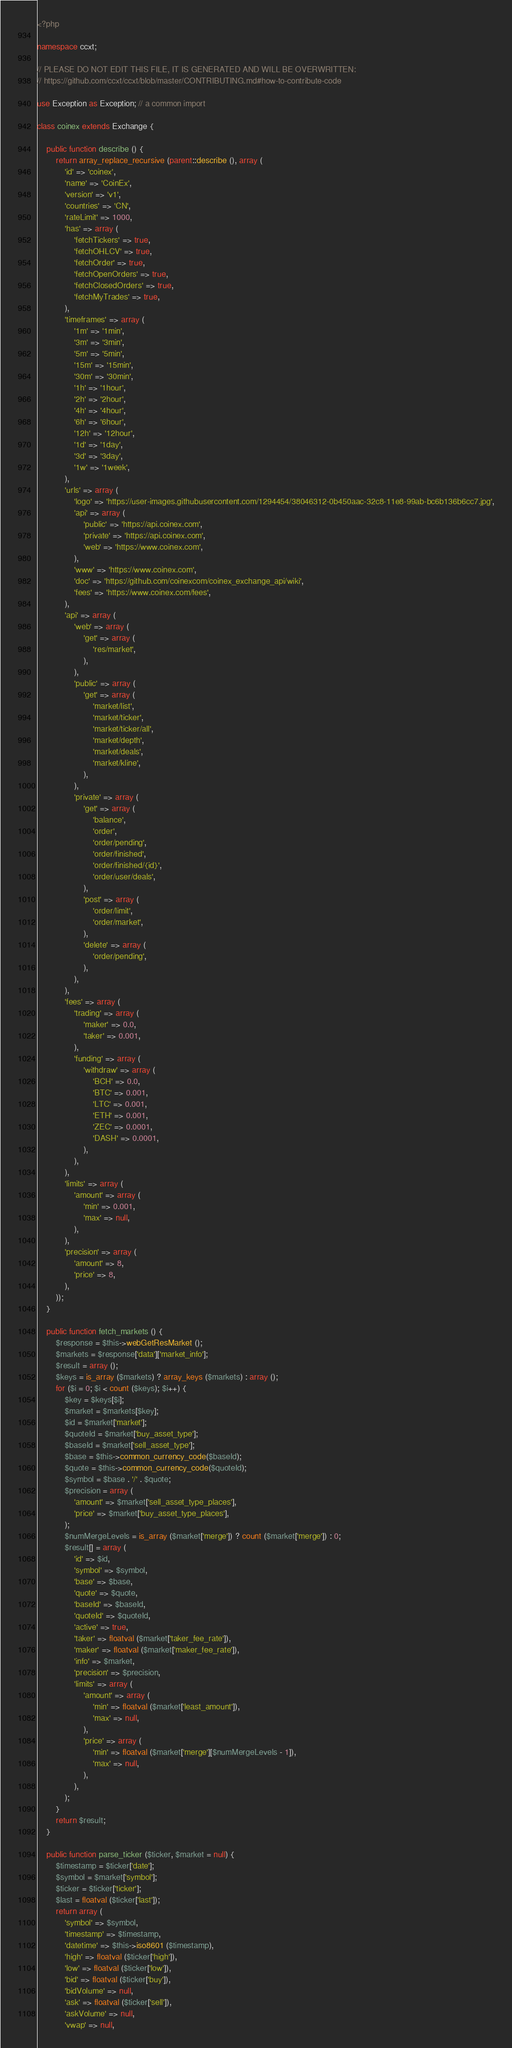<code> <loc_0><loc_0><loc_500><loc_500><_PHP_><?php

namespace ccxt;

// PLEASE DO NOT EDIT THIS FILE, IT IS GENERATED AND WILL BE OVERWRITTEN:
// https://github.com/ccxt/ccxt/blob/master/CONTRIBUTING.md#how-to-contribute-code

use Exception as Exception; // a common import

class coinex extends Exchange {

    public function describe () {
        return array_replace_recursive (parent::describe (), array (
            'id' => 'coinex',
            'name' => 'CoinEx',
            'version' => 'v1',
            'countries' => 'CN',
            'rateLimit' => 1000,
            'has' => array (
                'fetchTickers' => true,
                'fetchOHLCV' => true,
                'fetchOrder' => true,
                'fetchOpenOrders' => true,
                'fetchClosedOrders' => true,
                'fetchMyTrades' => true,
            ),
            'timeframes' => array (
                '1m' => '1min',
                '3m' => '3min',
                '5m' => '5min',
                '15m' => '15min',
                '30m' => '30min',
                '1h' => '1hour',
                '2h' => '2hour',
                '4h' => '4hour',
                '6h' => '6hour',
                '12h' => '12hour',
                '1d' => '1day',
                '3d' => '3day',
                '1w' => '1week',
            ),
            'urls' => array (
                'logo' => 'https://user-images.githubusercontent.com/1294454/38046312-0b450aac-32c8-11e8-99ab-bc6b136b6cc7.jpg',
                'api' => array (
                    'public' => 'https://api.coinex.com',
                    'private' => 'https://api.coinex.com',
                    'web' => 'https://www.coinex.com',
                ),
                'www' => 'https://www.coinex.com',
                'doc' => 'https://github.com/coinexcom/coinex_exchange_api/wiki',
                'fees' => 'https://www.coinex.com/fees',
            ),
            'api' => array (
                'web' => array (
                    'get' => array (
                        'res/market',
                    ),
                ),
                'public' => array (
                    'get' => array (
                        'market/list',
                        'market/ticker',
                        'market/ticker/all',
                        'market/depth',
                        'market/deals',
                        'market/kline',
                    ),
                ),
                'private' => array (
                    'get' => array (
                        'balance',
                        'order',
                        'order/pending',
                        'order/finished',
                        'order/finished/{id}',
                        'order/user/deals',
                    ),
                    'post' => array (
                        'order/limit',
                        'order/market',
                    ),
                    'delete' => array (
                        'order/pending',
                    ),
                ),
            ),
            'fees' => array (
                'trading' => array (
                    'maker' => 0.0,
                    'taker' => 0.001,
                ),
                'funding' => array (
                    'withdraw' => array (
                        'BCH' => 0.0,
                        'BTC' => 0.001,
                        'LTC' => 0.001,
                        'ETH' => 0.001,
                        'ZEC' => 0.0001,
                        'DASH' => 0.0001,
                    ),
                ),
            ),
            'limits' => array (
                'amount' => array (
                    'min' => 0.001,
                    'max' => null,
                ),
            ),
            'precision' => array (
                'amount' => 8,
                'price' => 8,
            ),
        ));
    }

    public function fetch_markets () {
        $response = $this->webGetResMarket ();
        $markets = $response['data']['market_info'];
        $result = array ();
        $keys = is_array ($markets) ? array_keys ($markets) : array ();
        for ($i = 0; $i < count ($keys); $i++) {
            $key = $keys[$i];
            $market = $markets[$key];
            $id = $market['market'];
            $quoteId = $market['buy_asset_type'];
            $baseId = $market['sell_asset_type'];
            $base = $this->common_currency_code($baseId);
            $quote = $this->common_currency_code($quoteId);
            $symbol = $base . '/' . $quote;
            $precision = array (
                'amount' => $market['sell_asset_type_places'],
                'price' => $market['buy_asset_type_places'],
            );
            $numMergeLevels = is_array ($market['merge']) ? count ($market['merge']) : 0;
            $result[] = array (
                'id' => $id,
                'symbol' => $symbol,
                'base' => $base,
                'quote' => $quote,
                'baseId' => $baseId,
                'quoteId' => $quoteId,
                'active' => true,
                'taker' => floatval ($market['taker_fee_rate']),
                'maker' => floatval ($market['maker_fee_rate']),
                'info' => $market,
                'precision' => $precision,
                'limits' => array (
                    'amount' => array (
                        'min' => floatval ($market['least_amount']),
                        'max' => null,
                    ),
                    'price' => array (
                        'min' => floatval ($market['merge'][$numMergeLevels - 1]),
                        'max' => null,
                    ),
                ),
            );
        }
        return $result;
    }

    public function parse_ticker ($ticker, $market = null) {
        $timestamp = $ticker['date'];
        $symbol = $market['symbol'];
        $ticker = $ticker['ticker'];
        $last = floatval ($ticker['last']);
        return array (
            'symbol' => $symbol,
            'timestamp' => $timestamp,
            'datetime' => $this->iso8601 ($timestamp),
            'high' => floatval ($ticker['high']),
            'low' => floatval ($ticker['low']),
            'bid' => floatval ($ticker['buy']),
            'bidVolume' => null,
            'ask' => floatval ($ticker['sell']),
            'askVolume' => null,
            'vwap' => null,</code> 